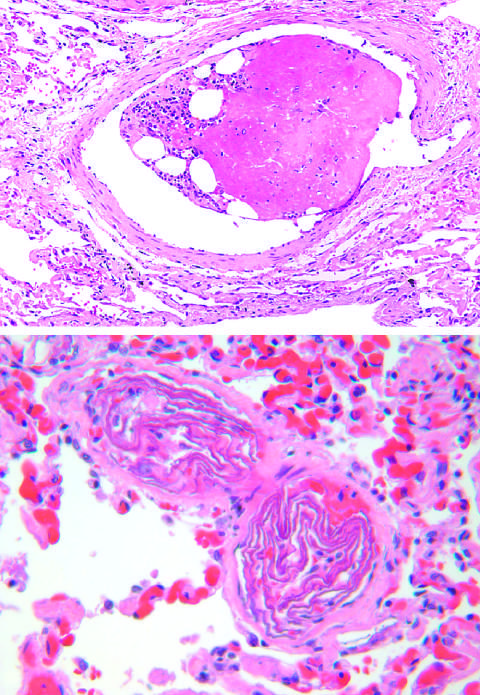s the wall of the artery composed of hematopoietic marrow and marrow fat cells attached to a thrombus?
Answer the question using a single word or phrase. No 